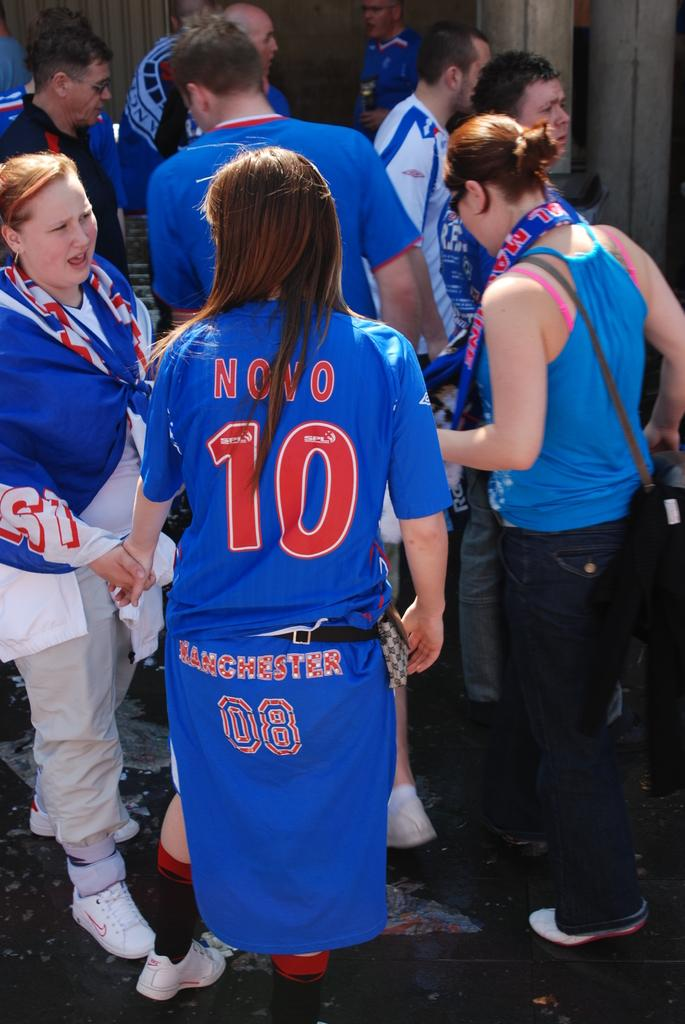<image>
Render a clear and concise summary of the photo. Some sports players, the number 10 is visible in red on the back of one of them. 